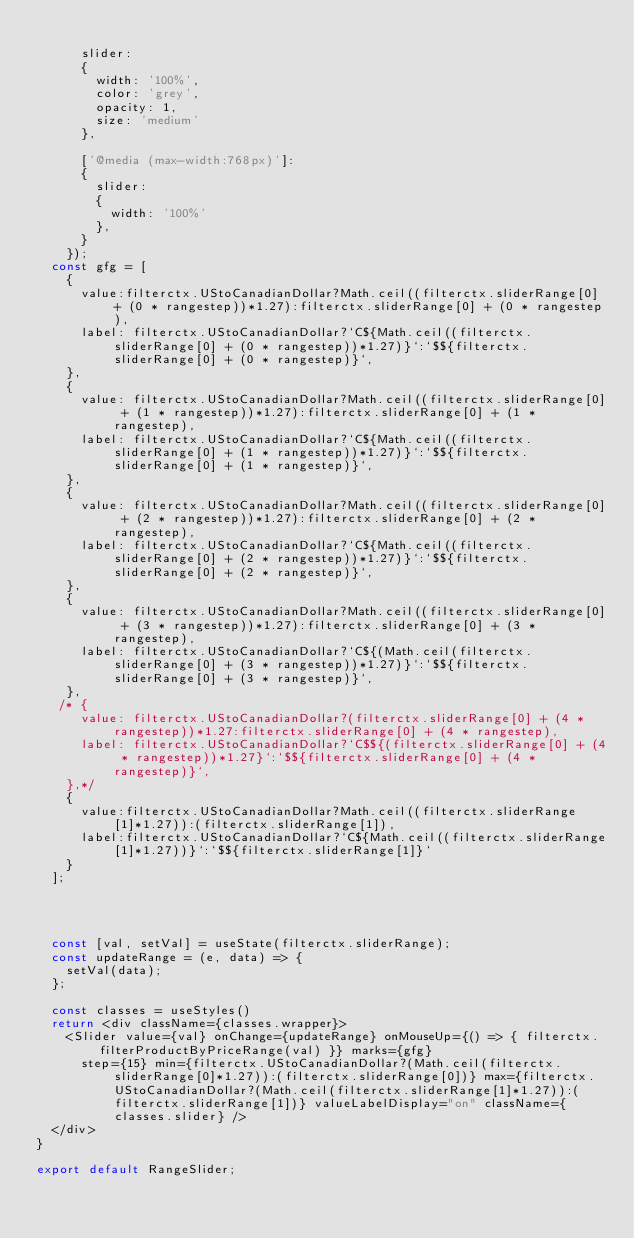Convert code to text. <code><loc_0><loc_0><loc_500><loc_500><_JavaScript_>
      slider:
      {
        width: '100%',
        color: 'grey',
        opacity: 1,
        size: 'medium'
      },

      ['@media (max-width:768px)']:
      {
        slider:
        {
          width: '100%'
        },
      }
    });
  const gfg = [
    {
      value:filterctx.UStoCanadianDollar?Math.ceil((filterctx.sliderRange[0] + (0 * rangestep))*1.27):filterctx.sliderRange[0] + (0 * rangestep),
      label: filterctx.UStoCanadianDollar?`C${Math.ceil((filterctx.sliderRange[0] + (0 * rangestep))*1.27)}`:`$${filterctx.sliderRange[0] + (0 * rangestep)}`,
    },
    {
      value: filterctx.UStoCanadianDollar?Math.ceil((filterctx.sliderRange[0] + (1 * rangestep))*1.27):filterctx.sliderRange[0] + (1 * rangestep),
      label: filterctx.UStoCanadianDollar?`C${Math.ceil((filterctx.sliderRange[0] + (1 * rangestep))*1.27)}`:`$${filterctx.sliderRange[0] + (1 * rangestep)}`,
    },
    {
      value: filterctx.UStoCanadianDollar?Math.ceil((filterctx.sliderRange[0] + (2 * rangestep))*1.27):filterctx.sliderRange[0] + (2 * rangestep),
      label: filterctx.UStoCanadianDollar?`C${Math.ceil((filterctx.sliderRange[0] + (2 * rangestep))*1.27)}`:`$${filterctx.sliderRange[0] + (2 * rangestep)}`,
    },
    {
      value: filterctx.UStoCanadianDollar?Math.ceil((filterctx.sliderRange[0] + (3 * rangestep))*1.27):filterctx.sliderRange[0] + (3 * rangestep),
      label: filterctx.UStoCanadianDollar?`C${(Math.ceil(filterctx.sliderRange[0] + (3 * rangestep))*1.27)}`:`$${filterctx.sliderRange[0] + (3 * rangestep)}`,
    },
   /* {
      value: filterctx.UStoCanadianDollar?(filterctx.sliderRange[0] + (4 * rangestep))*1.27:filterctx.sliderRange[0] + (4 * rangestep),
      label: filterctx.UStoCanadianDollar?`C$${(filterctx.sliderRange[0] + (4 * rangestep))*1.27}`:`$${filterctx.sliderRange[0] + (4 * rangestep)}`,
    },*/
    {
      value:filterctx.UStoCanadianDollar?Math.ceil((filterctx.sliderRange[1]*1.27)):(filterctx.sliderRange[1]),
      label:filterctx.UStoCanadianDollar?`C${Math.ceil((filterctx.sliderRange[1]*1.27))}`:`$${filterctx.sliderRange[1]}`
    }
  ];

  


  const [val, setVal] = useState(filterctx.sliderRange);
  const updateRange = (e, data) => {
    setVal(data);
  };

  const classes = useStyles()
  return <div className={classes.wrapper}>
    <Slider value={val} onChange={updateRange} onMouseUp={() => { filterctx.filterProductByPriceRange(val) }} marks={gfg}
      step={15} min={filterctx.UStoCanadianDollar?(Math.ceil(filterctx.sliderRange[0]*1.27)):(filterctx.sliderRange[0])} max={filterctx.UStoCanadianDollar?(Math.ceil(filterctx.sliderRange[1]*1.27)):(filterctx.sliderRange[1])} valueLabelDisplay="on" className={classes.slider} />
  </div>
}

export default RangeSlider;</code> 